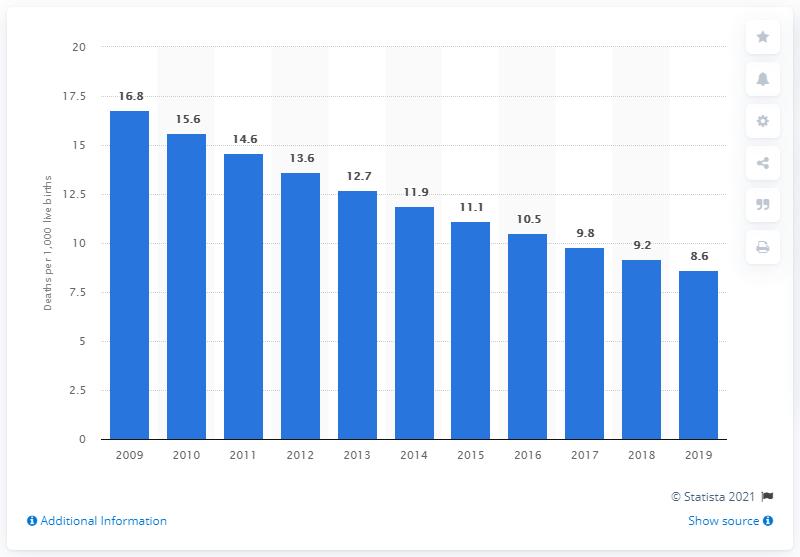Outline some significant characteristics in this image. The infant mortality rate in Turkey in 2019 was 8.6 deaths per 1,000 live births, according to recent data. 